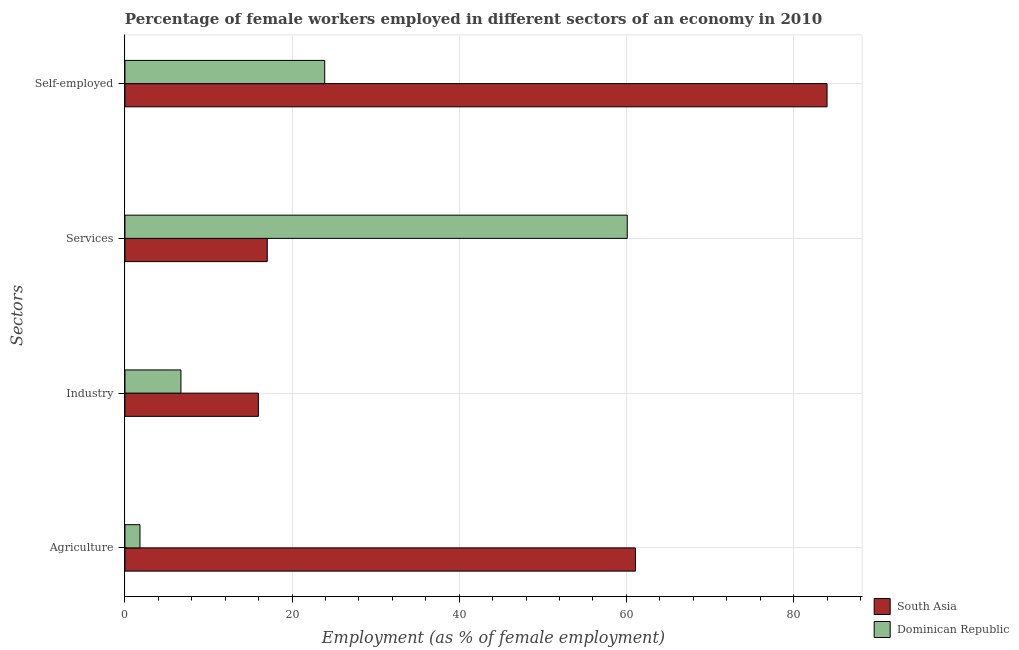How many different coloured bars are there?
Give a very brief answer. 2. How many groups of bars are there?
Your answer should be very brief. 4. Are the number of bars per tick equal to the number of legend labels?
Keep it short and to the point. Yes. What is the label of the 4th group of bars from the top?
Provide a short and direct response. Agriculture. What is the percentage of self employed female workers in Dominican Republic?
Give a very brief answer. 23.9. Across all countries, what is the maximum percentage of female workers in services?
Ensure brevity in your answer.  60.1. Across all countries, what is the minimum percentage of female workers in services?
Your response must be concise. 17.03. What is the total percentage of female workers in services in the graph?
Ensure brevity in your answer.  77.13. What is the difference between the percentage of female workers in agriculture in Dominican Republic and that in South Asia?
Give a very brief answer. -59.28. What is the difference between the percentage of female workers in agriculture in South Asia and the percentage of female workers in services in Dominican Republic?
Keep it short and to the point. 0.98. What is the average percentage of female workers in agriculture per country?
Your response must be concise. 31.44. What is the difference between the percentage of self employed female workers and percentage of female workers in agriculture in South Asia?
Provide a short and direct response. 22.93. What is the ratio of the percentage of female workers in services in Dominican Republic to that in South Asia?
Offer a very short reply. 3.53. What is the difference between the highest and the second highest percentage of self employed female workers?
Keep it short and to the point. 60.11. What is the difference between the highest and the lowest percentage of self employed female workers?
Your response must be concise. 60.11. Is it the case that in every country, the sum of the percentage of female workers in services and percentage of female workers in industry is greater than the sum of percentage of female workers in agriculture and percentage of self employed female workers?
Provide a succinct answer. No. What does the 1st bar from the top in Industry represents?
Make the answer very short. Dominican Republic. What does the 1st bar from the bottom in Services represents?
Make the answer very short. South Asia. Are all the bars in the graph horizontal?
Provide a succinct answer. Yes. How many countries are there in the graph?
Your answer should be very brief. 2. What is the difference between two consecutive major ticks on the X-axis?
Keep it short and to the point. 20. Are the values on the major ticks of X-axis written in scientific E-notation?
Offer a very short reply. No. Does the graph contain any zero values?
Offer a very short reply. No. How many legend labels are there?
Provide a succinct answer. 2. How are the legend labels stacked?
Offer a terse response. Vertical. What is the title of the graph?
Provide a succinct answer. Percentage of female workers employed in different sectors of an economy in 2010. Does "Zimbabwe" appear as one of the legend labels in the graph?
Your answer should be compact. No. What is the label or title of the X-axis?
Make the answer very short. Employment (as % of female employment). What is the label or title of the Y-axis?
Offer a very short reply. Sectors. What is the Employment (as % of female employment) in South Asia in Agriculture?
Ensure brevity in your answer.  61.08. What is the Employment (as % of female employment) of Dominican Republic in Agriculture?
Offer a terse response. 1.8. What is the Employment (as % of female employment) of South Asia in Industry?
Offer a very short reply. 15.96. What is the Employment (as % of female employment) in Dominican Republic in Industry?
Your answer should be compact. 6.7. What is the Employment (as % of female employment) in South Asia in Services?
Provide a succinct answer. 17.03. What is the Employment (as % of female employment) of Dominican Republic in Services?
Offer a terse response. 60.1. What is the Employment (as % of female employment) of South Asia in Self-employed?
Give a very brief answer. 84.01. What is the Employment (as % of female employment) in Dominican Republic in Self-employed?
Keep it short and to the point. 23.9. Across all Sectors, what is the maximum Employment (as % of female employment) of South Asia?
Offer a very short reply. 84.01. Across all Sectors, what is the maximum Employment (as % of female employment) of Dominican Republic?
Provide a short and direct response. 60.1. Across all Sectors, what is the minimum Employment (as % of female employment) of South Asia?
Ensure brevity in your answer.  15.96. Across all Sectors, what is the minimum Employment (as % of female employment) in Dominican Republic?
Give a very brief answer. 1.8. What is the total Employment (as % of female employment) in South Asia in the graph?
Your answer should be very brief. 178.08. What is the total Employment (as % of female employment) of Dominican Republic in the graph?
Keep it short and to the point. 92.5. What is the difference between the Employment (as % of female employment) in South Asia in Agriculture and that in Industry?
Provide a succinct answer. 45.11. What is the difference between the Employment (as % of female employment) of South Asia in Agriculture and that in Services?
Provide a short and direct response. 44.05. What is the difference between the Employment (as % of female employment) of Dominican Republic in Agriculture and that in Services?
Your response must be concise. -58.3. What is the difference between the Employment (as % of female employment) in South Asia in Agriculture and that in Self-employed?
Your answer should be very brief. -22.93. What is the difference between the Employment (as % of female employment) of Dominican Republic in Agriculture and that in Self-employed?
Your response must be concise. -22.1. What is the difference between the Employment (as % of female employment) in South Asia in Industry and that in Services?
Your answer should be very brief. -1.06. What is the difference between the Employment (as % of female employment) in Dominican Republic in Industry and that in Services?
Your answer should be very brief. -53.4. What is the difference between the Employment (as % of female employment) in South Asia in Industry and that in Self-employed?
Make the answer very short. -68.04. What is the difference between the Employment (as % of female employment) of Dominican Republic in Industry and that in Self-employed?
Give a very brief answer. -17.2. What is the difference between the Employment (as % of female employment) in South Asia in Services and that in Self-employed?
Make the answer very short. -66.98. What is the difference between the Employment (as % of female employment) of Dominican Republic in Services and that in Self-employed?
Offer a terse response. 36.2. What is the difference between the Employment (as % of female employment) in South Asia in Agriculture and the Employment (as % of female employment) in Dominican Republic in Industry?
Your answer should be compact. 54.38. What is the difference between the Employment (as % of female employment) in South Asia in Agriculture and the Employment (as % of female employment) in Dominican Republic in Self-employed?
Ensure brevity in your answer.  37.18. What is the difference between the Employment (as % of female employment) in South Asia in Industry and the Employment (as % of female employment) in Dominican Republic in Services?
Provide a succinct answer. -44.14. What is the difference between the Employment (as % of female employment) of South Asia in Industry and the Employment (as % of female employment) of Dominican Republic in Self-employed?
Provide a succinct answer. -7.94. What is the difference between the Employment (as % of female employment) in South Asia in Services and the Employment (as % of female employment) in Dominican Republic in Self-employed?
Provide a succinct answer. -6.87. What is the average Employment (as % of female employment) in South Asia per Sectors?
Your answer should be very brief. 44.52. What is the average Employment (as % of female employment) in Dominican Republic per Sectors?
Provide a short and direct response. 23.12. What is the difference between the Employment (as % of female employment) of South Asia and Employment (as % of female employment) of Dominican Republic in Agriculture?
Your response must be concise. 59.28. What is the difference between the Employment (as % of female employment) of South Asia and Employment (as % of female employment) of Dominican Republic in Industry?
Provide a short and direct response. 9.26. What is the difference between the Employment (as % of female employment) in South Asia and Employment (as % of female employment) in Dominican Republic in Services?
Ensure brevity in your answer.  -43.07. What is the difference between the Employment (as % of female employment) of South Asia and Employment (as % of female employment) of Dominican Republic in Self-employed?
Make the answer very short. 60.11. What is the ratio of the Employment (as % of female employment) of South Asia in Agriculture to that in Industry?
Provide a succinct answer. 3.83. What is the ratio of the Employment (as % of female employment) of Dominican Republic in Agriculture to that in Industry?
Offer a very short reply. 0.27. What is the ratio of the Employment (as % of female employment) of South Asia in Agriculture to that in Services?
Your answer should be compact. 3.59. What is the ratio of the Employment (as % of female employment) of Dominican Republic in Agriculture to that in Services?
Provide a short and direct response. 0.03. What is the ratio of the Employment (as % of female employment) in South Asia in Agriculture to that in Self-employed?
Your answer should be compact. 0.73. What is the ratio of the Employment (as % of female employment) in Dominican Republic in Agriculture to that in Self-employed?
Your response must be concise. 0.08. What is the ratio of the Employment (as % of female employment) in Dominican Republic in Industry to that in Services?
Your response must be concise. 0.11. What is the ratio of the Employment (as % of female employment) of South Asia in Industry to that in Self-employed?
Keep it short and to the point. 0.19. What is the ratio of the Employment (as % of female employment) of Dominican Republic in Industry to that in Self-employed?
Offer a terse response. 0.28. What is the ratio of the Employment (as % of female employment) in South Asia in Services to that in Self-employed?
Make the answer very short. 0.2. What is the ratio of the Employment (as % of female employment) in Dominican Republic in Services to that in Self-employed?
Provide a short and direct response. 2.51. What is the difference between the highest and the second highest Employment (as % of female employment) in South Asia?
Keep it short and to the point. 22.93. What is the difference between the highest and the second highest Employment (as % of female employment) in Dominican Republic?
Offer a very short reply. 36.2. What is the difference between the highest and the lowest Employment (as % of female employment) in South Asia?
Give a very brief answer. 68.04. What is the difference between the highest and the lowest Employment (as % of female employment) in Dominican Republic?
Your answer should be compact. 58.3. 